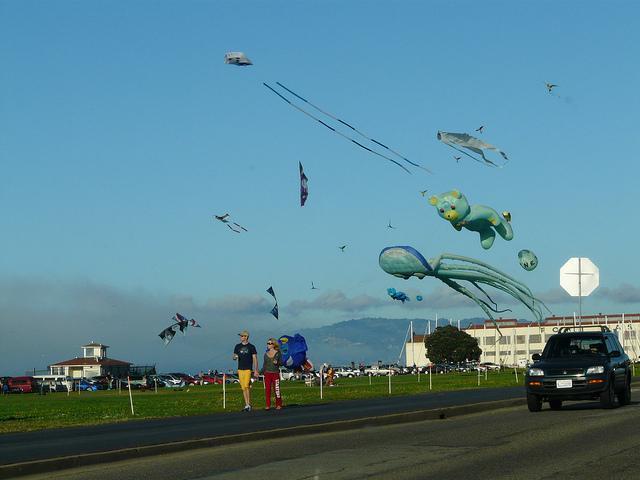How many cars are there?
Give a very brief answer. 2. How many kites are there?
Give a very brief answer. 3. 